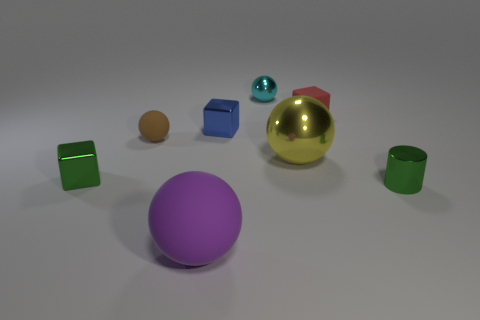There is a small thing right of the small red object to the right of the small metal block behind the green cube; what is its shape?
Offer a terse response. Cylinder. The small cyan metal object has what shape?
Your answer should be compact. Sphere. What color is the metal block that is on the right side of the tiny brown thing?
Provide a succinct answer. Blue. There is a rubber object that is in front of the metallic cylinder; is its size the same as the brown thing?
Give a very brief answer. No. What is the size of the purple thing that is the same shape as the yellow metallic object?
Give a very brief answer. Large. Is there anything else that has the same size as the red rubber cube?
Keep it short and to the point. Yes. Is the shape of the yellow shiny object the same as the tiny red thing?
Your answer should be compact. No. Are there fewer things that are behind the red object than small objects behind the purple rubber object?
Your answer should be very brief. Yes. What number of shiny things are on the right side of the purple matte ball?
Provide a succinct answer. 4. Does the small thing that is in front of the green metal block have the same shape as the tiny green object to the left of the purple rubber object?
Provide a short and direct response. No. 